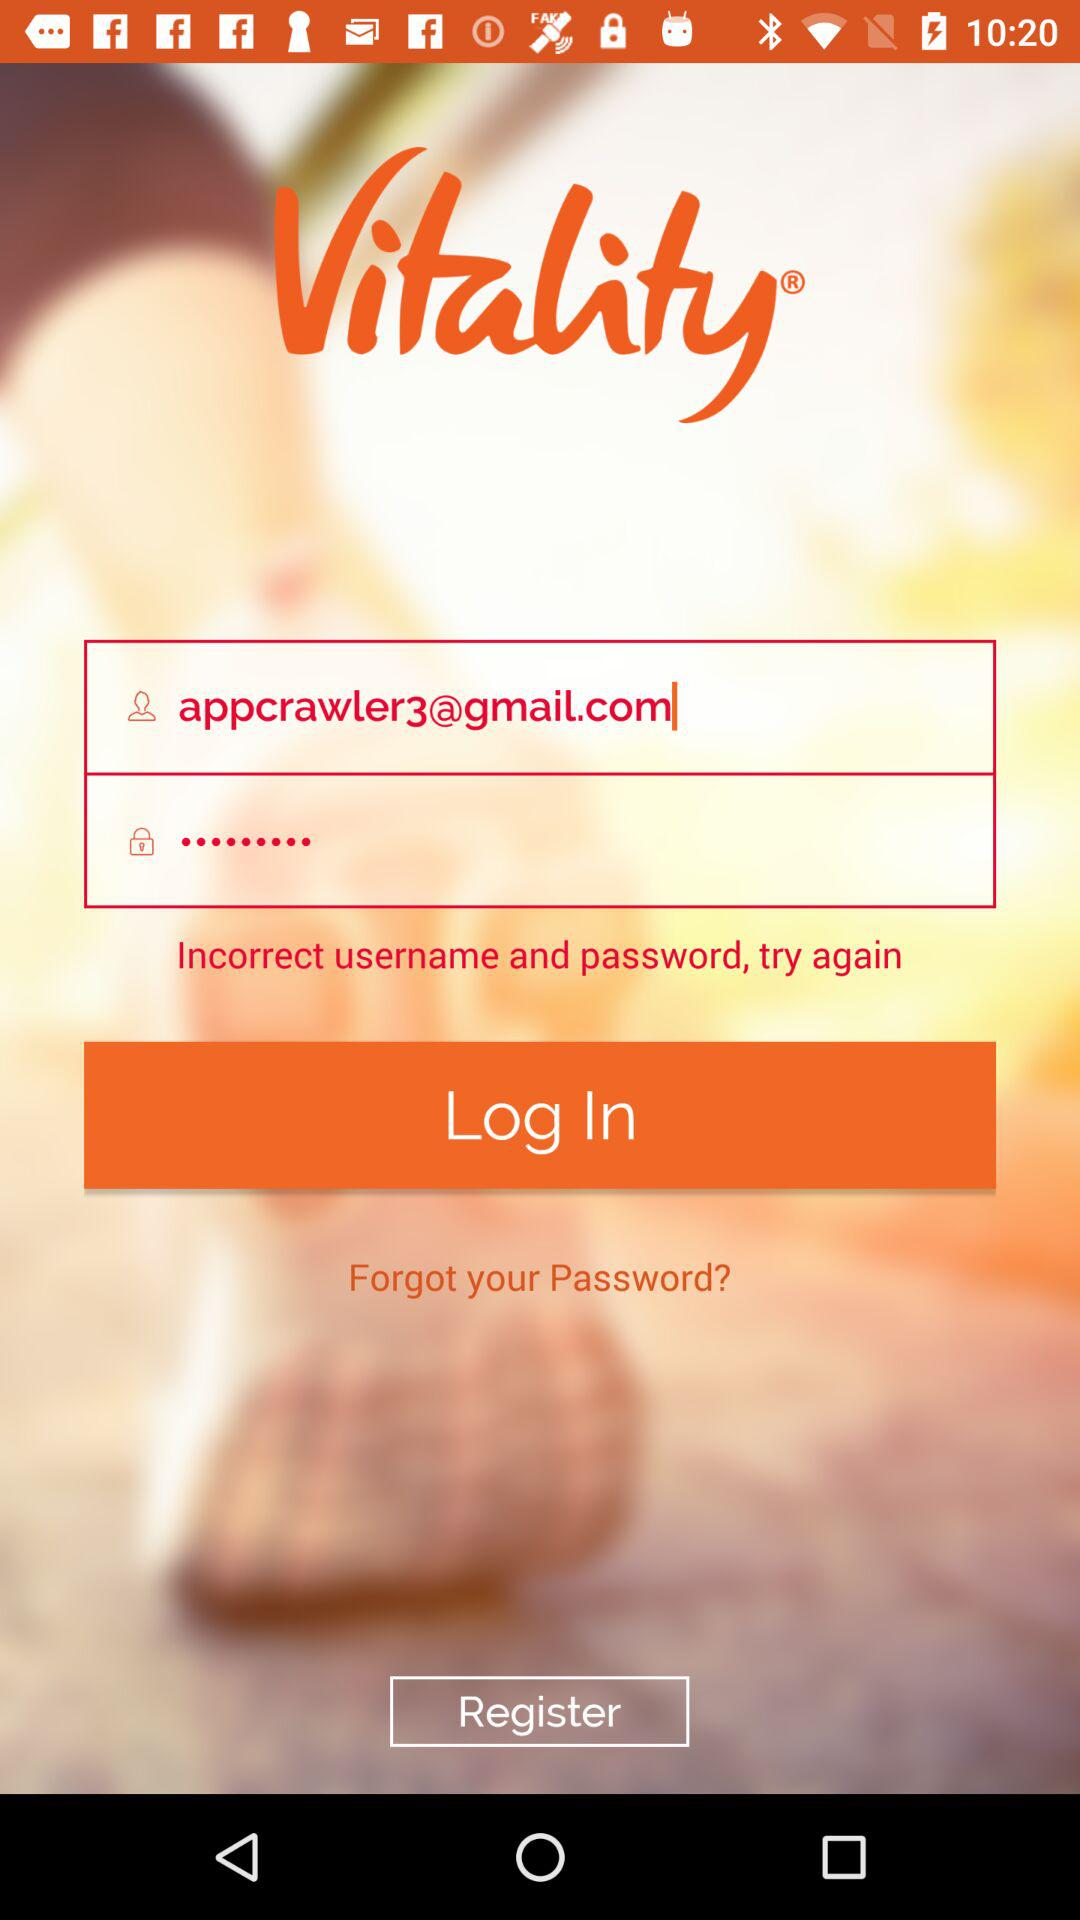What is the email address? The email address is appcrawler3@gmail.com. 